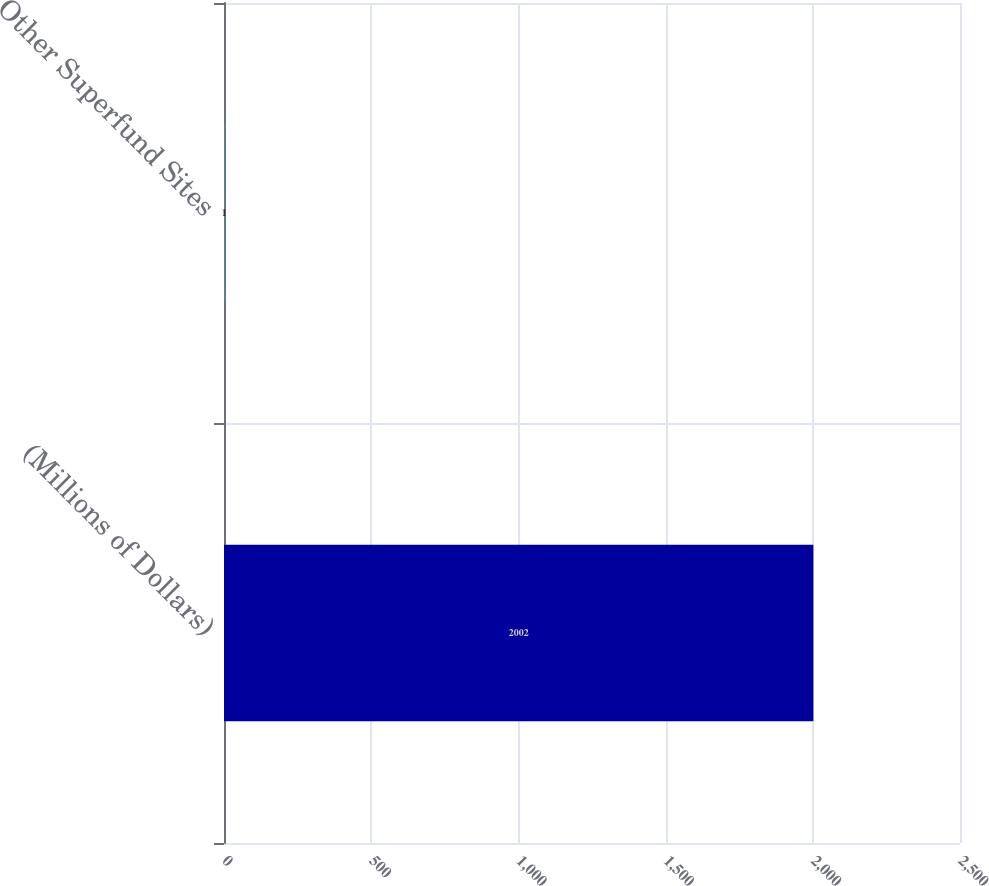<chart> <loc_0><loc_0><loc_500><loc_500><bar_chart><fcel>(Millions of Dollars)<fcel>Other Superfund Sites<nl><fcel>2002<fcel>1<nl></chart> 